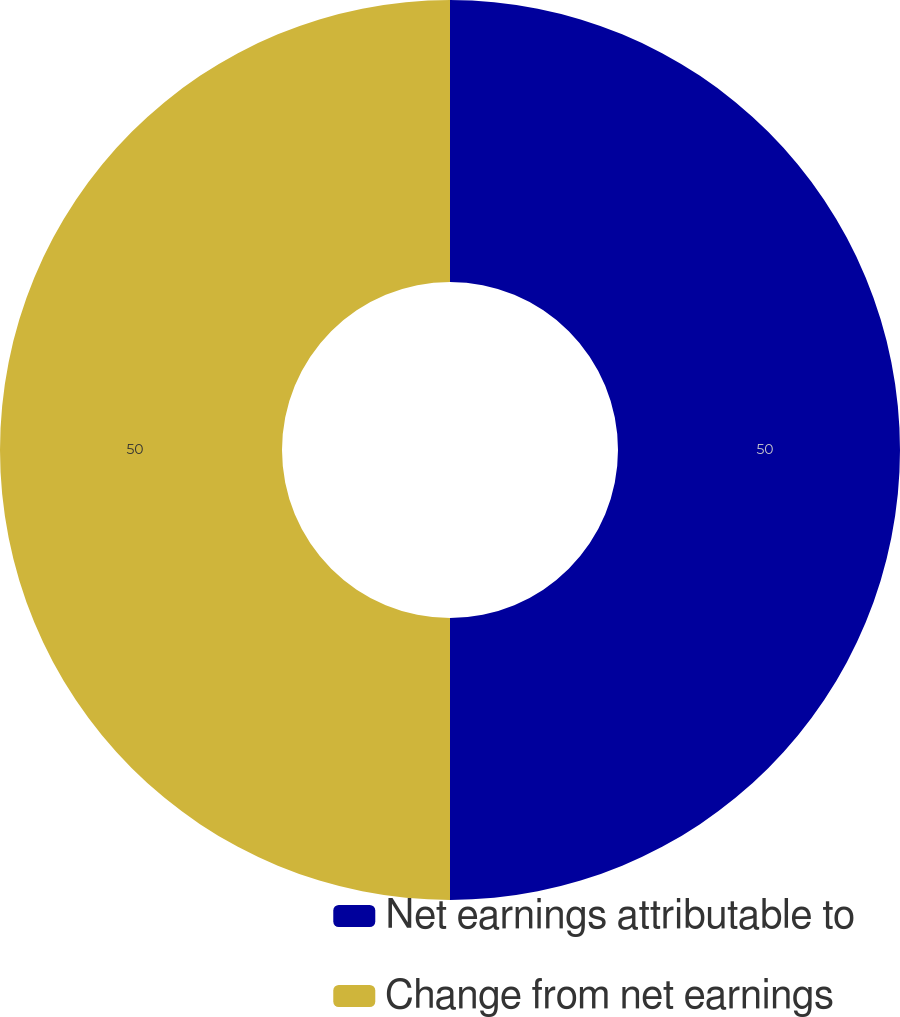Convert chart. <chart><loc_0><loc_0><loc_500><loc_500><pie_chart><fcel>Net earnings attributable to<fcel>Change from net earnings<nl><fcel>50.0%<fcel>50.0%<nl></chart> 